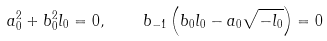Convert formula to latex. <formula><loc_0><loc_0><loc_500><loc_500>a _ { 0 } ^ { 2 } + b _ { 0 } ^ { 2 } l _ { 0 } = 0 , \quad b _ { - 1 } \left ( b _ { 0 } l _ { 0 } - a _ { 0 } \sqrt { - l _ { 0 } } \right ) = 0</formula> 